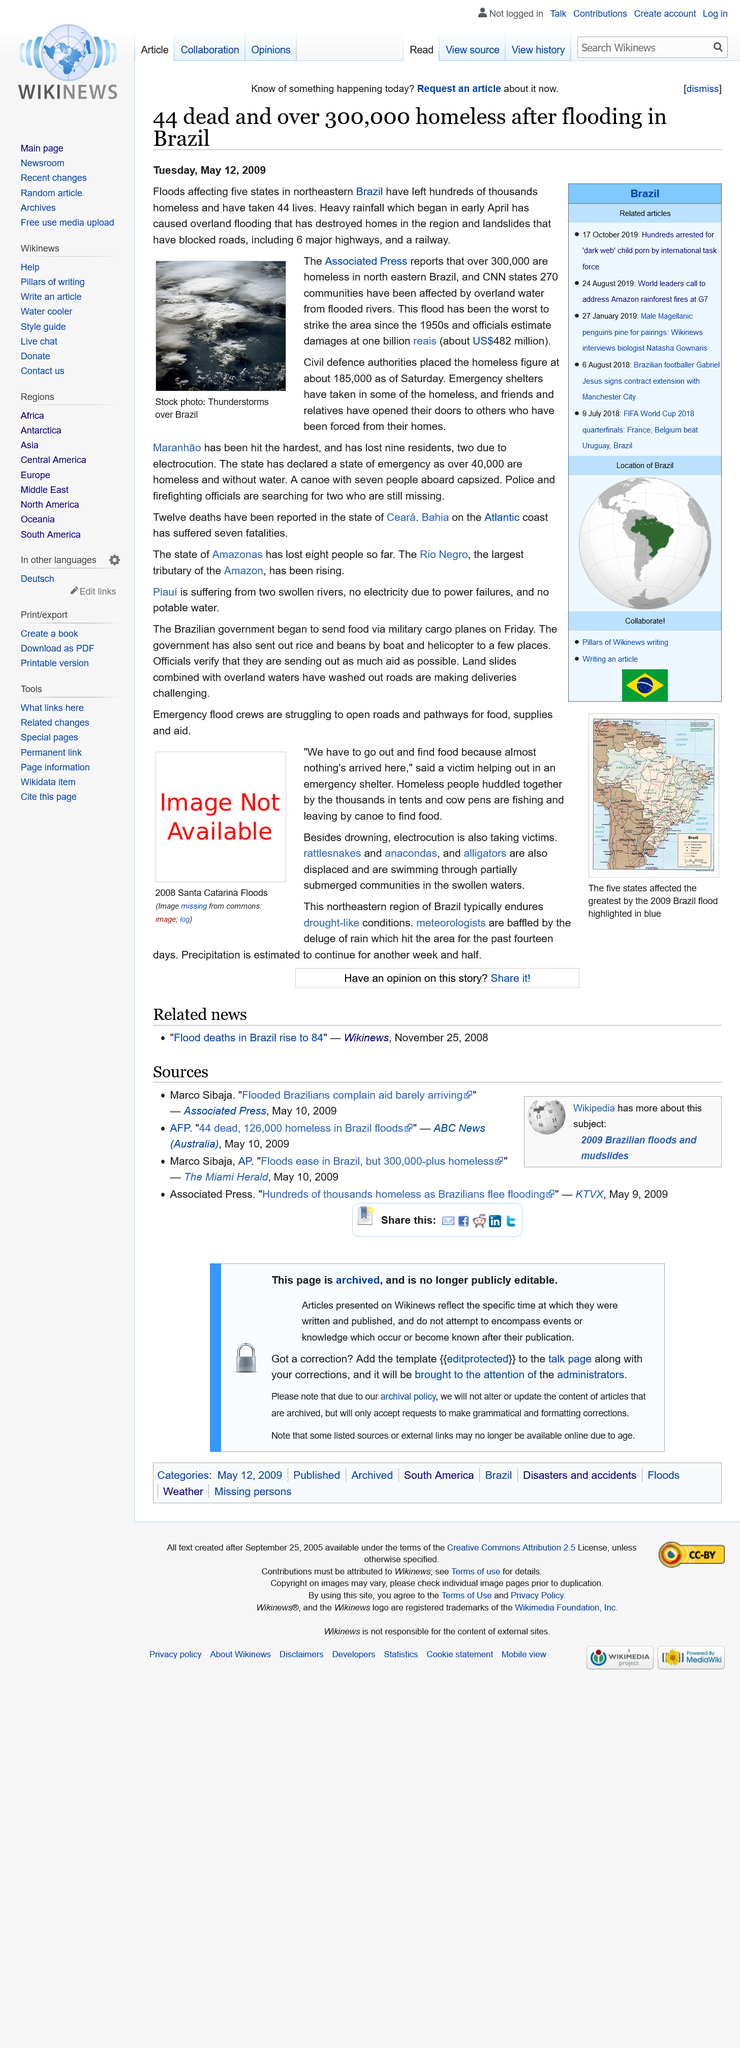Mention a couple of crucial points in this snapshot. The Rio Negro is the largest tributary of the Amazon, which is the world's largest river by discharge. The 2008 Santa Catarina Floods caused thousands of homeless people to huddle together in tents, leaving them without shelter and protection from the elements. As of now, two individuals are still missing in the state of Maranhão. This flood, which has been the most devastating to affect the region since the 1950s, has caused significant damage to homes and infrastructure. It is imperative that if one has opinions on this story, they should share them. 